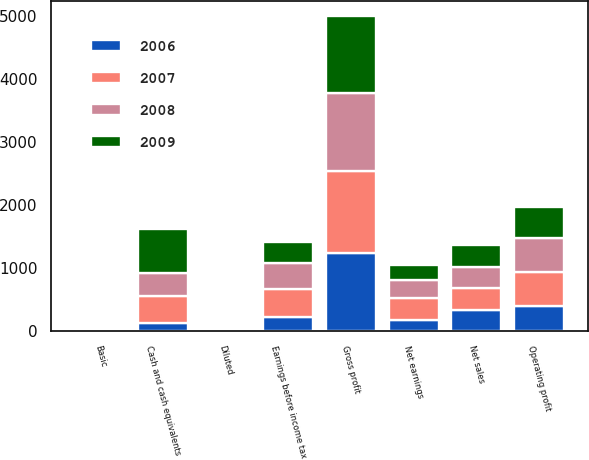<chart> <loc_0><loc_0><loc_500><loc_500><stacked_bar_chart><ecel><fcel>Net sales<fcel>Gross profit<fcel>Operating profit<fcel>Earnings before income tax<fcel>Net earnings<fcel>Basic<fcel>Diluted<fcel>Cash and cash equivalents<nl><fcel>2009<fcel>341.45<fcel>1218.5<fcel>492.3<fcel>329.9<fcel>244.3<fcel>1.54<fcel>1.35<fcel>694.5<nl><fcel>2006<fcel>341.45<fcel>1236.6<fcel>396.5<fcel>222.3<fcel>179.9<fcel>1.13<fcel>0.99<fcel>128.9<nl><fcel>2007<fcel>341.45<fcel>1301.1<fcel>549.3<fcel>456<fcel>353<fcel>2.19<fcel>1.88<fcel>430.3<nl><fcel>2008<fcel>341.45<fcel>1240.1<fcel>526.1<fcel>400.1<fcel>274.1<fcel>1.69<fcel>1.46<fcel>373.1<nl></chart> 